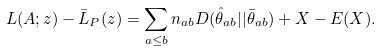Convert formula to latex. <formula><loc_0><loc_0><loc_500><loc_500>L ( A ; z ) - \bar { L } _ { P } ( z ) = \sum _ { a \leq b } n _ { a b } D ( \hat { \theta } _ { a b } | | \bar { \theta } _ { a b } ) + X - E ( X ) .</formula> 